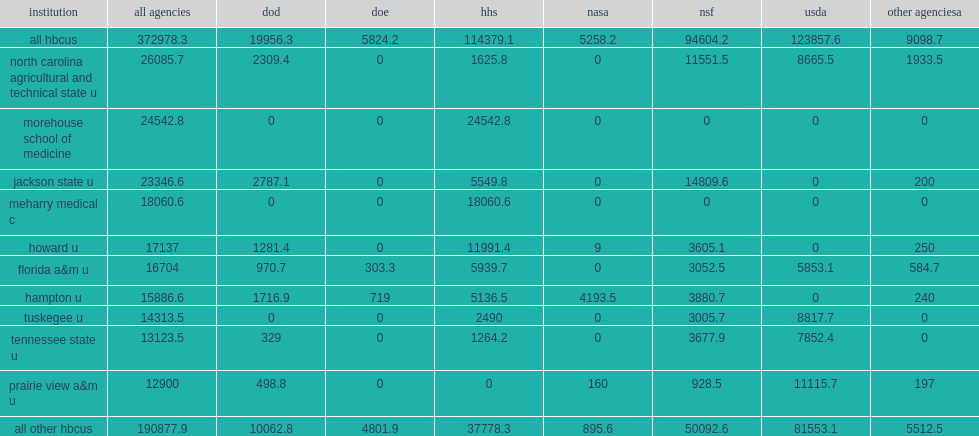Sixty-six of the 105 hbcus2 received federal obligations for s&e support, how many thousand dollars totaled? 372978.3. 